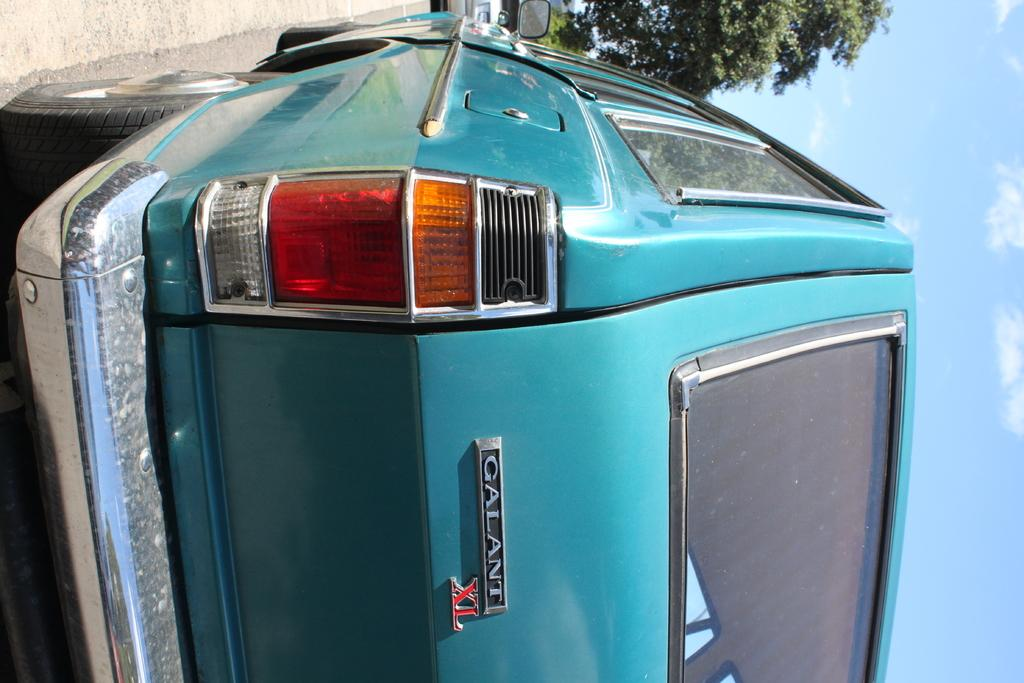What can be seen on the road in the image? There are vehicles on the road in the image. What type of skirt is being traded on the road in the image? There is no skirt or trade activity present in the image; it features vehicles on the road. What flavor of cracker is being consumed by the vehicles in the image? There are no crackers present in the image, and vehicles do not consume food. 